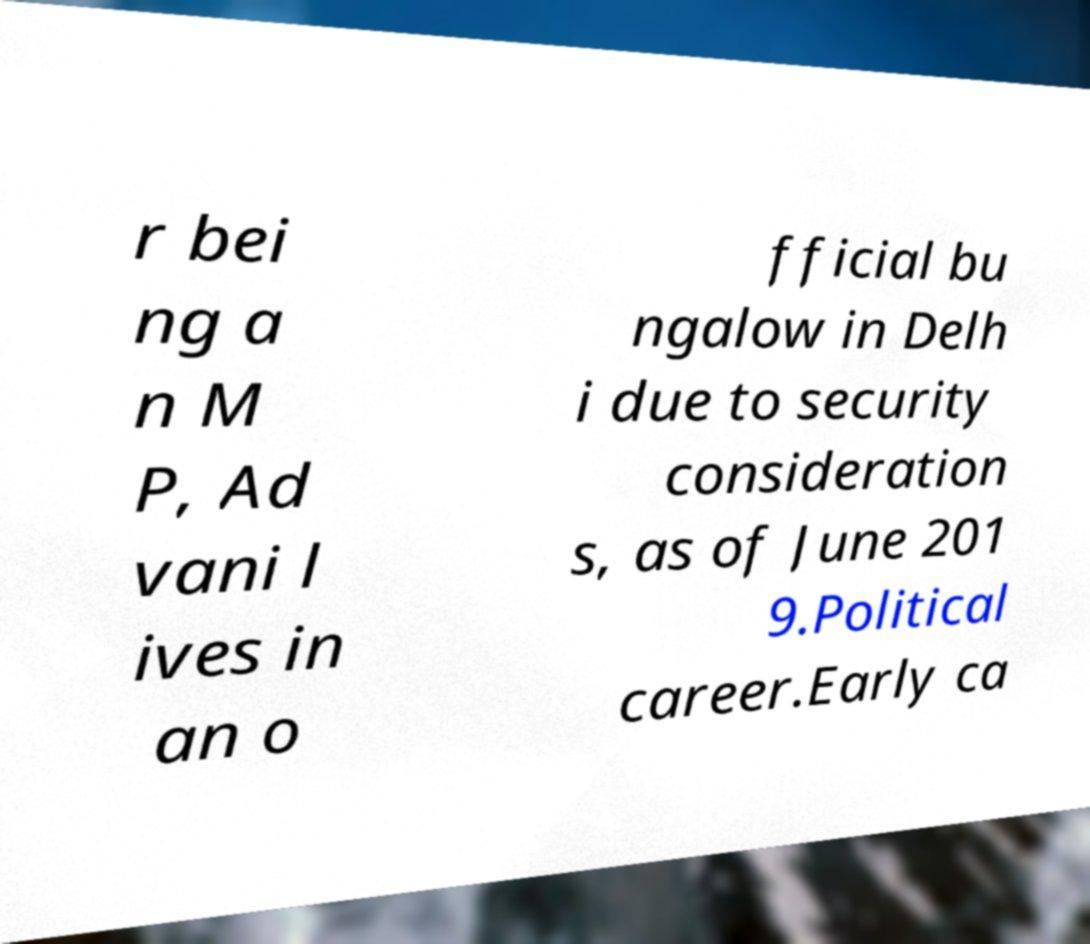I need the written content from this picture converted into text. Can you do that? r bei ng a n M P, Ad vani l ives in an o fficial bu ngalow in Delh i due to security consideration s, as of June 201 9.Political career.Early ca 